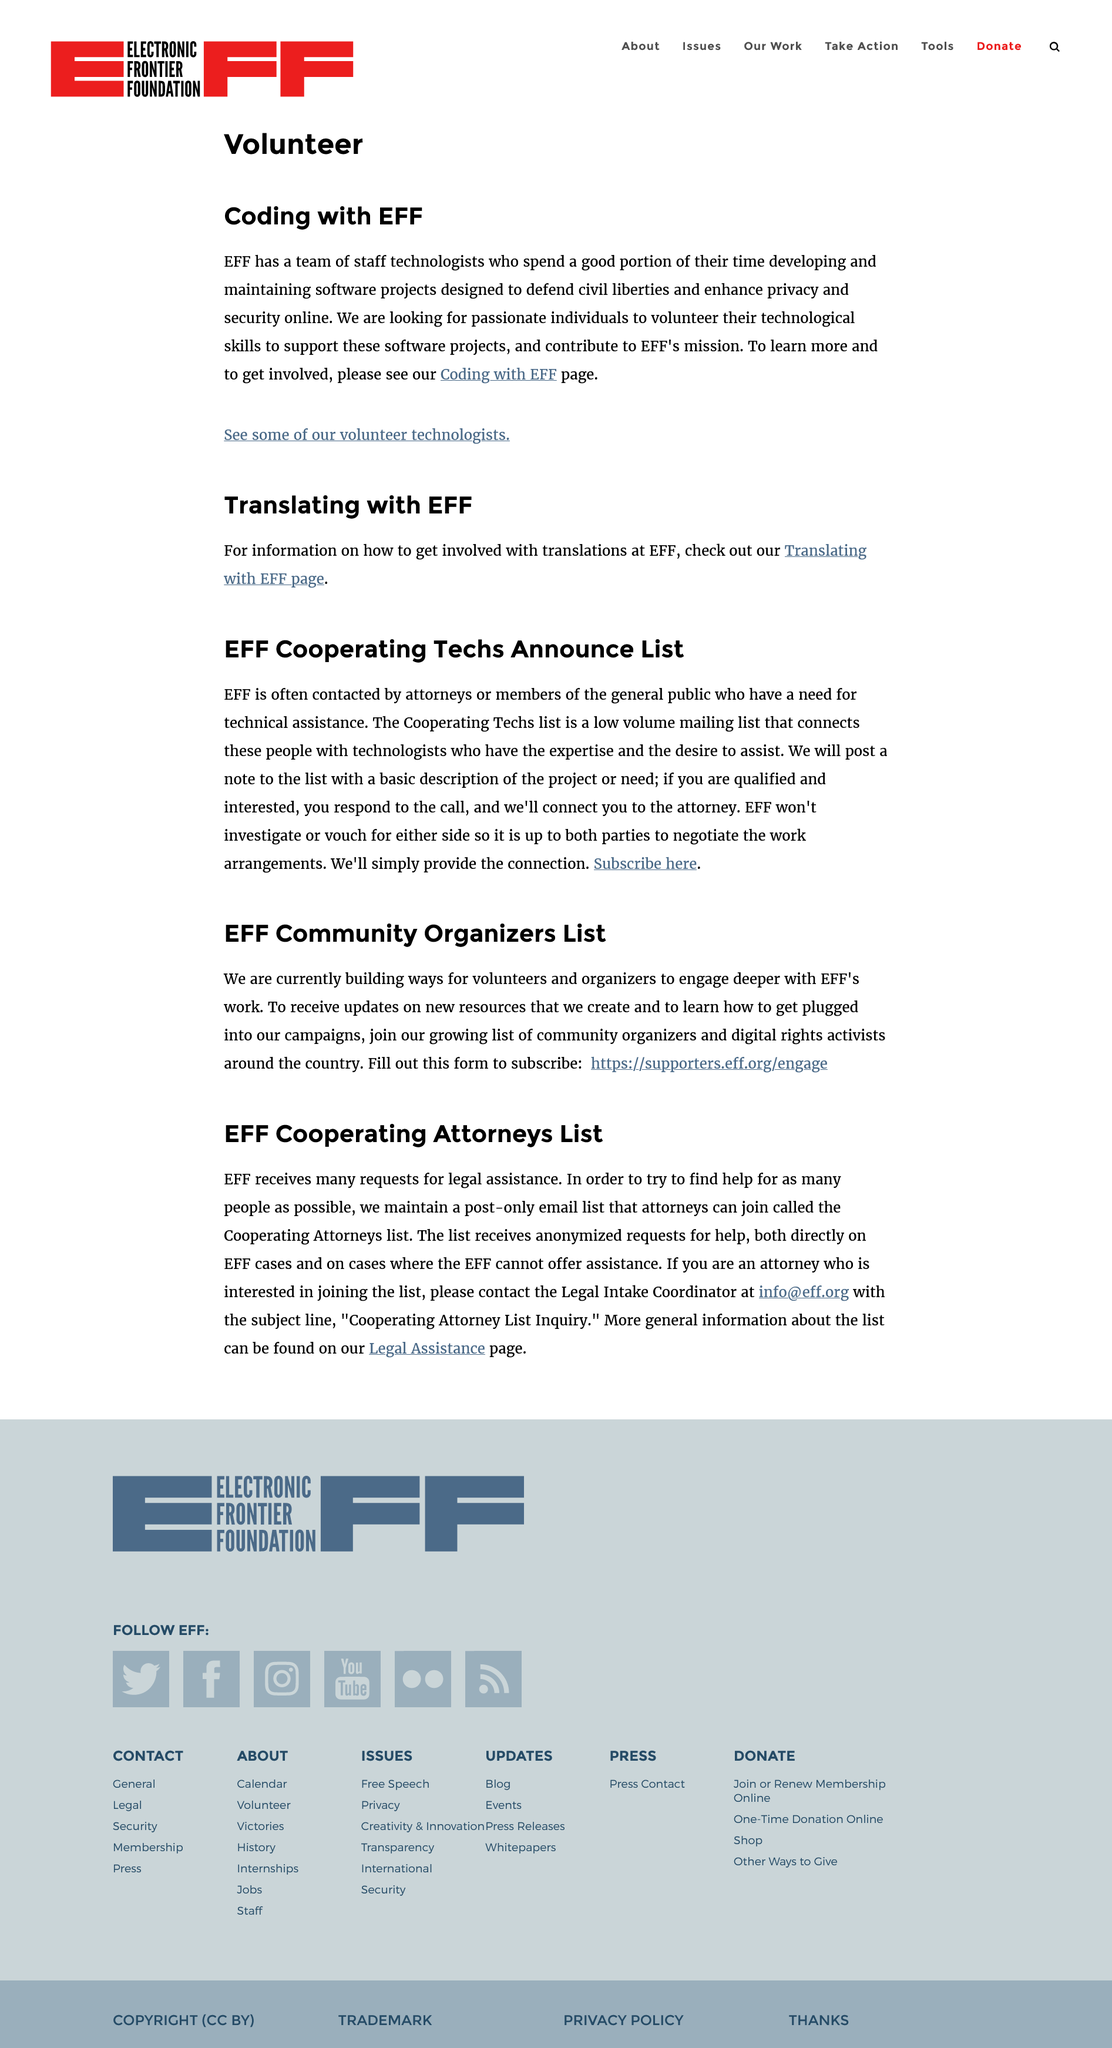Specify some key components in this picture. EFF is currently seeking individuals to contribute to its mission by coding, and they are looking for qualified individuals to do so. The EFF Cooperating Attorneys List is the second subheading. The Electronic Frontier Foundation (EFF) is seeking passionate individuals to volunteer their technological skills to support our mission. If you have experience in programming, web development, or other technical areas, we would love to hear from you. As a volunteer, you will have the opportunity to contribute to important projects, learn new skills, and make a difference in the fight for digital rights. Join the EFF and help us defend freedom in the digital world. There are two subheadings on the page. The EFF Community Organisers List is the first subheading. 